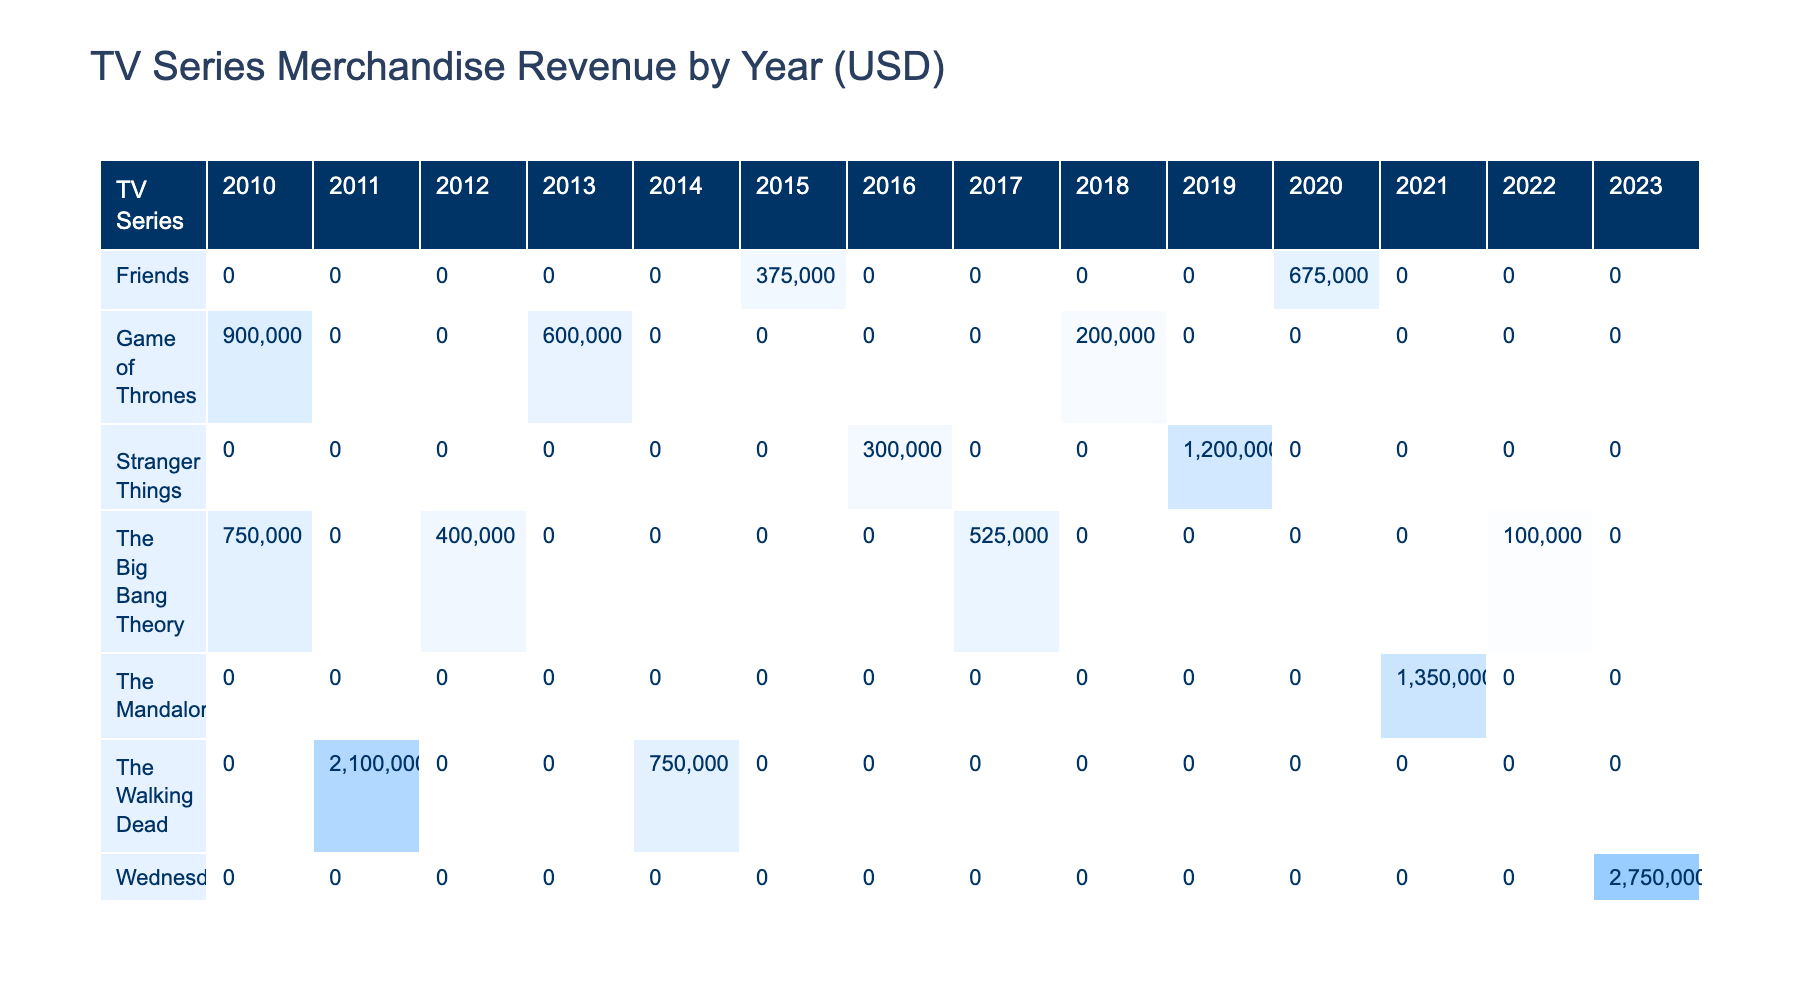What was the total revenue generated by merchandise from "The Big Bang Theory" over all years listed? To find the total revenue for "The Big Bang Theory", we add its revenue from each year: 750000 (2010) + 400000 (2012) + 525000 (2017) + 100000 (2022) = 1975000.
Answer: 1975000 Which TV series had the highest merchandise sales in 2021? In 2021, "The Mandalorian" had merchandise sales of 1350000, which is higher than any other series that year.
Answer: The Mandalorian What is the average revenue for "Stranger Things" merchandise sales over the years? "Stranger Things" had revenues of 300000 (2016) + 1200000 (2019) = 1500000. There are 2 years, so the average is 1500000 / 2 = 750000.
Answer: 750000 Did "Game of Thrones" sell more merchandise units in 2010 than in 2018? In 2010, "Game of Thrones" sold 30000 units, while in 2018, it sold 10000 units. Since 30000 is greater than 10000, the answer is yes.
Answer: Yes What was the percentage increase in revenue for "The Walking Dead" from 2011 to 2014? The revenue in 2011 was 2100000 and in 2014 was 750000. The decrease is 2100000 - 750000 = 1350000. The percentage decrease is (1350000 / 2100000) * 100 = 64.29%.
Answer: 64.29% Which merchandise type generated the highest revenue for "Wednesday" in 2023? "Wednesday" sold action figures worth 2750000 in 2023, which is the only entry for that year. Thus, it generated the highest revenue by default.
Answer: Action Figures How much more revenue did "Friends" generate from merchandise in 2020 compared to 2015? "Friends" generated revenue of 675000 in 2020 and 375000 in 2015. The difference is 675000 - 375000 = 300000.
Answer: 300000 Which TV series had no merchandise sales recorded in 2012? By checking the list, "The Walking Dead" and "Friends" both have no sales in 2012; therefore, these are the series without any recorded merchandise sales that year.
Answer: The Walking Dead, Friends 